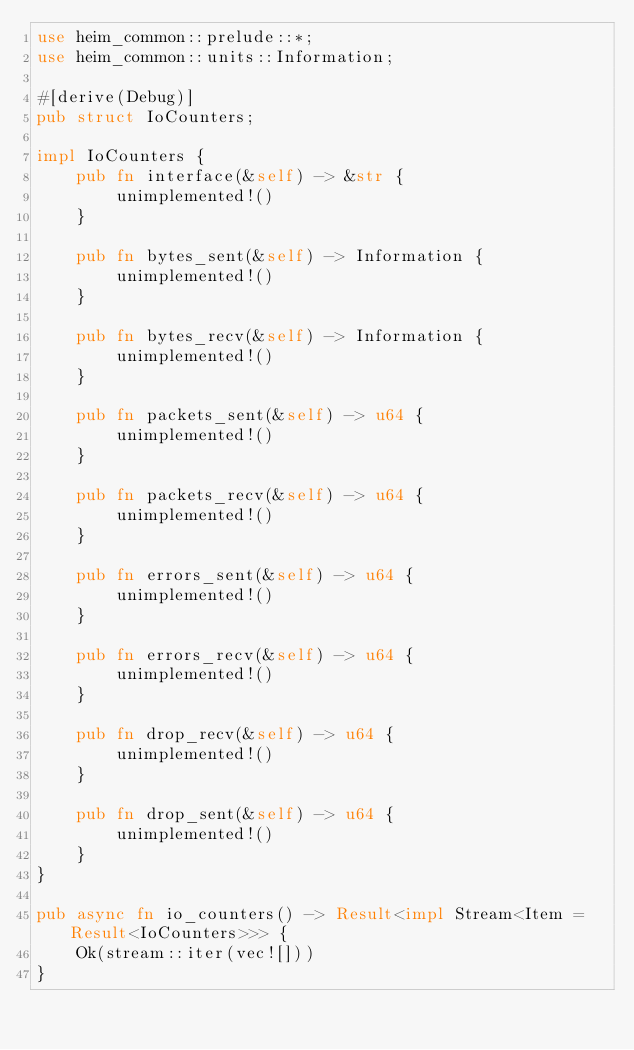<code> <loc_0><loc_0><loc_500><loc_500><_Rust_>use heim_common::prelude::*;
use heim_common::units::Information;

#[derive(Debug)]
pub struct IoCounters;

impl IoCounters {
    pub fn interface(&self) -> &str {
        unimplemented!()
    }

    pub fn bytes_sent(&self) -> Information {
        unimplemented!()
    }

    pub fn bytes_recv(&self) -> Information {
        unimplemented!()
    }

    pub fn packets_sent(&self) -> u64 {
        unimplemented!()
    }

    pub fn packets_recv(&self) -> u64 {
        unimplemented!()
    }

    pub fn errors_sent(&self) -> u64 {
        unimplemented!()
    }

    pub fn errors_recv(&self) -> u64 {
        unimplemented!()
    }

    pub fn drop_recv(&self) -> u64 {
        unimplemented!()
    }

    pub fn drop_sent(&self) -> u64 {
        unimplemented!()
    }
}

pub async fn io_counters() -> Result<impl Stream<Item = Result<IoCounters>>> {
    Ok(stream::iter(vec![]))
}
</code> 